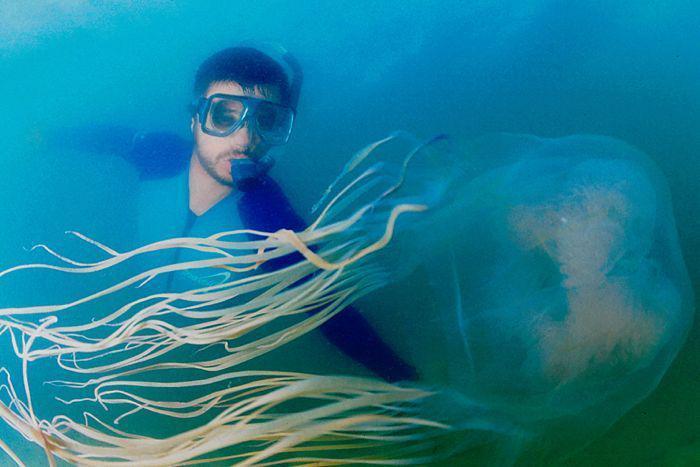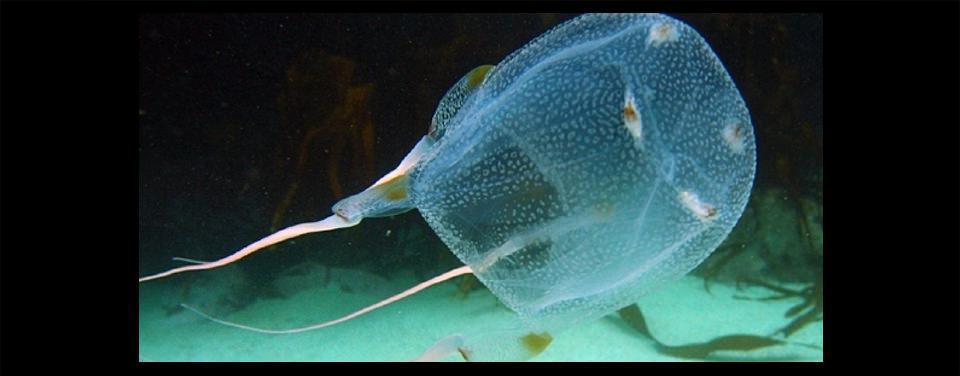The first image is the image on the left, the second image is the image on the right. For the images displayed, is the sentence "The jellyfish is swimming to the left in the image on the left" factually correct? Answer yes or no. No. 